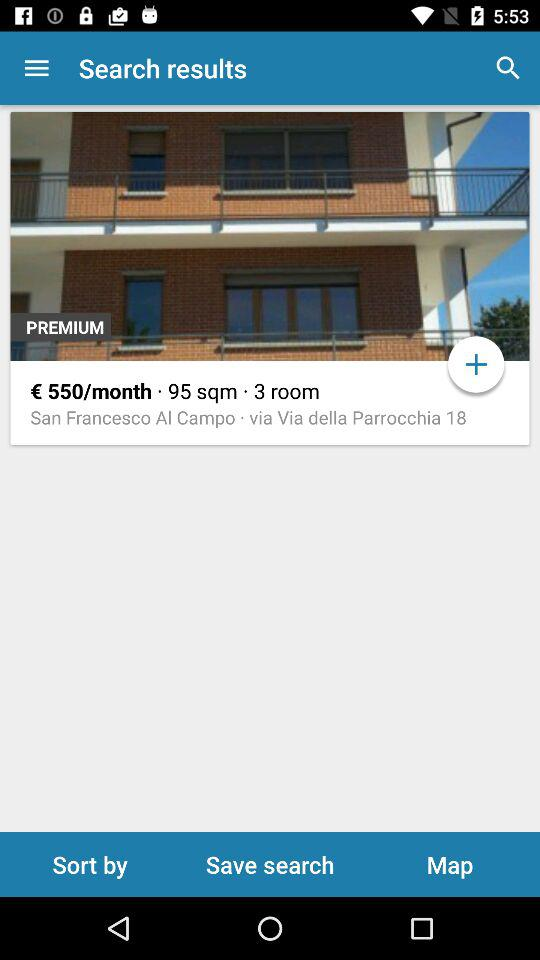How many euros per month is this place?
Answer the question using a single word or phrase. 550 